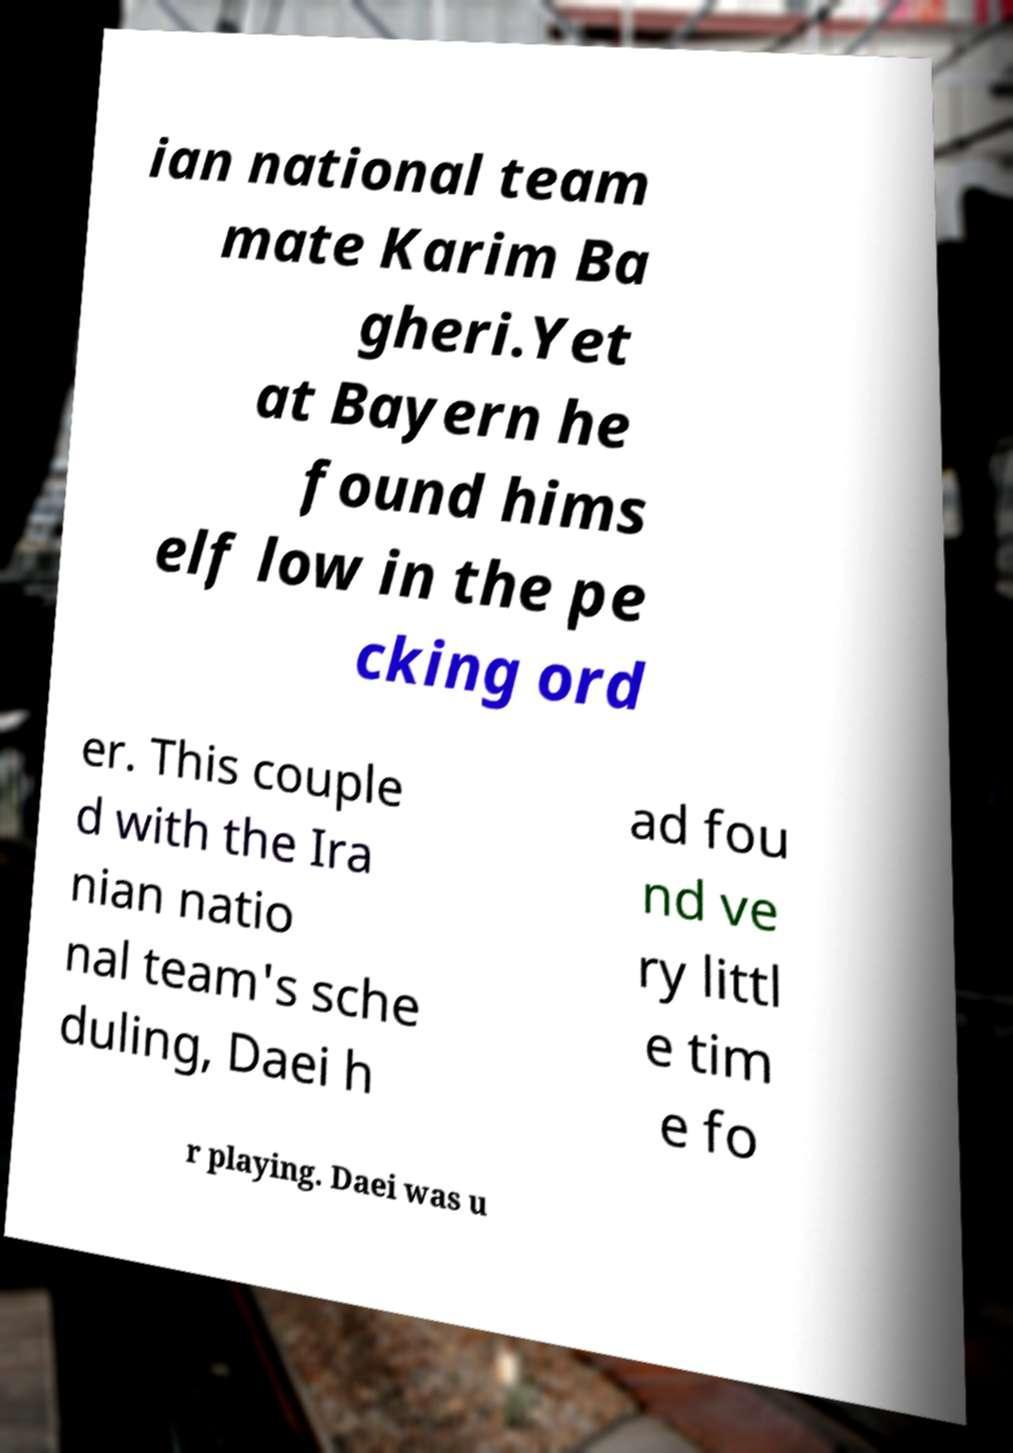Can you accurately transcribe the text from the provided image for me? ian national team mate Karim Ba gheri.Yet at Bayern he found hims elf low in the pe cking ord er. This couple d with the Ira nian natio nal team's sche duling, Daei h ad fou nd ve ry littl e tim e fo r playing. Daei was u 